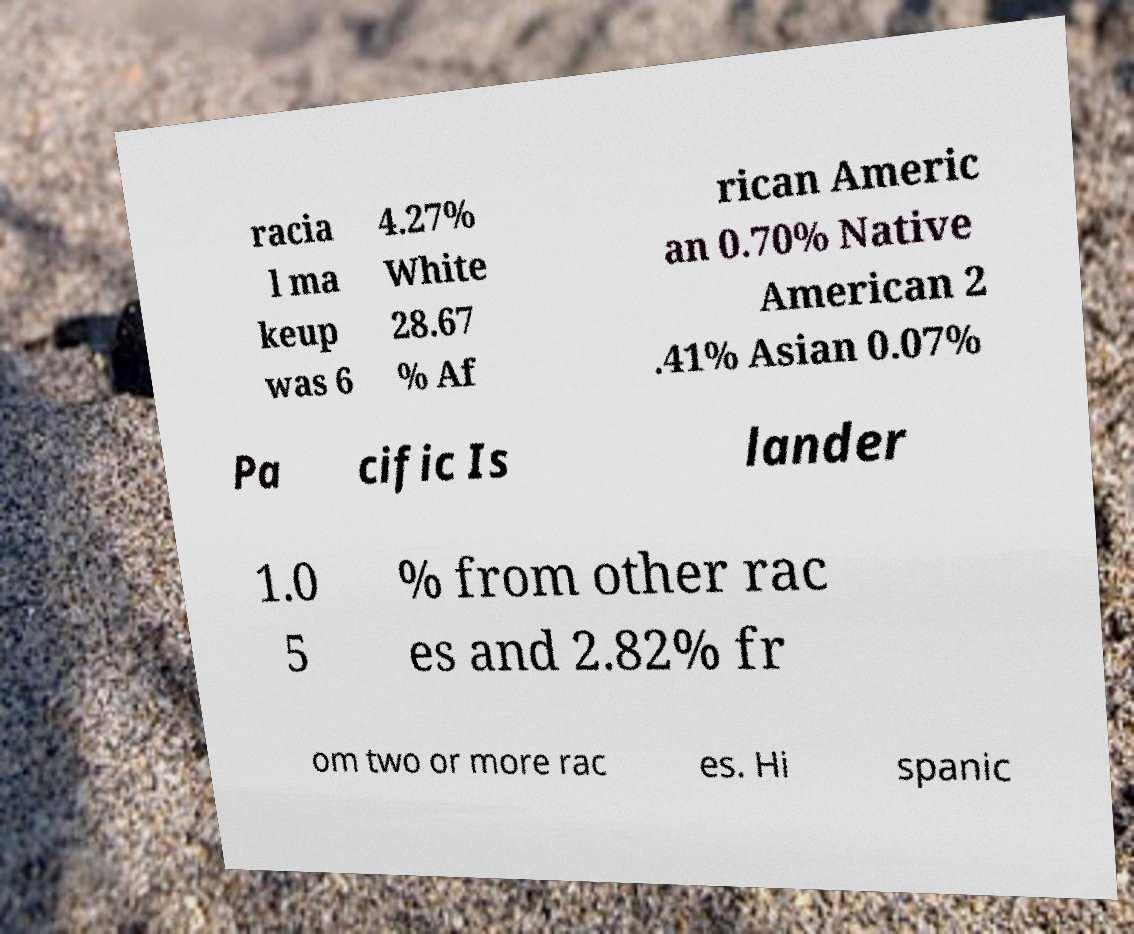I need the written content from this picture converted into text. Can you do that? racia l ma keup was 6 4.27% White 28.67 % Af rican Americ an 0.70% Native American 2 .41% Asian 0.07% Pa cific Is lander 1.0 5 % from other rac es and 2.82% fr om two or more rac es. Hi spanic 